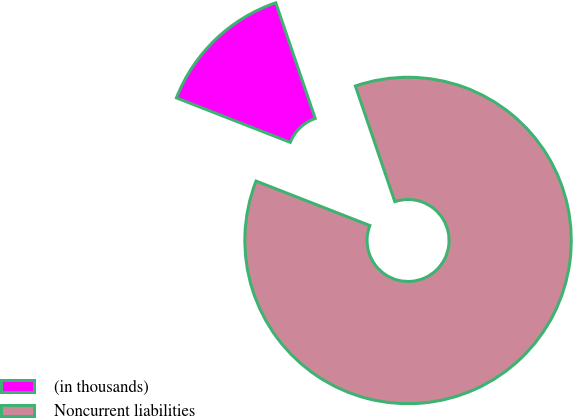<chart> <loc_0><loc_0><loc_500><loc_500><pie_chart><fcel>(in thousands)<fcel>Noncurrent liabilities<nl><fcel>13.84%<fcel>86.16%<nl></chart> 